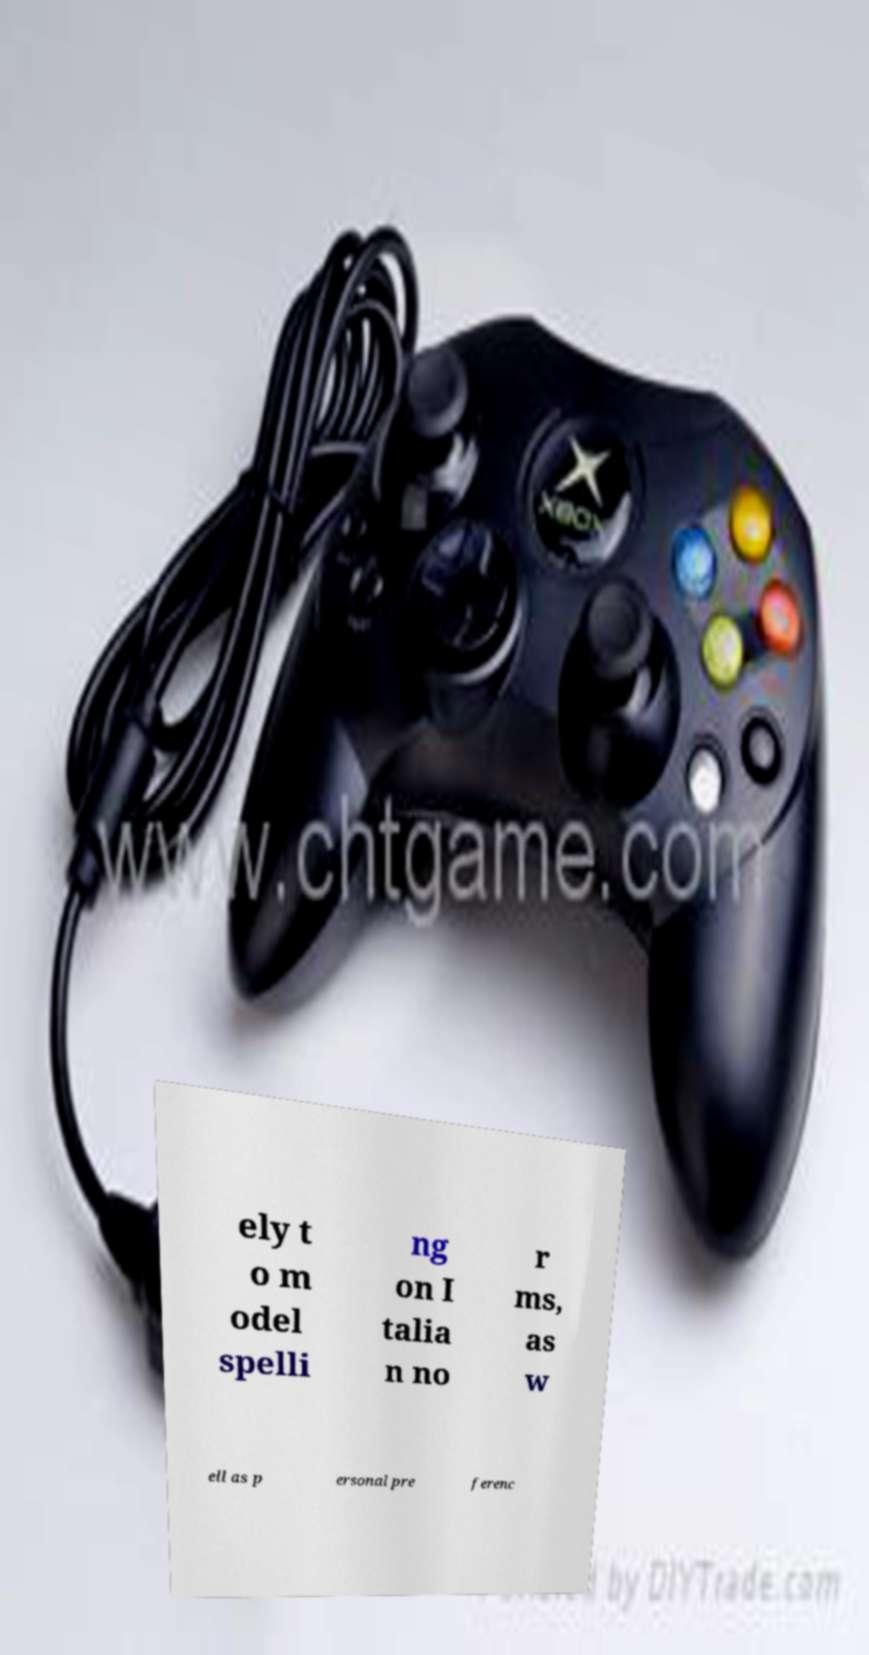I need the written content from this picture converted into text. Can you do that? ely t o m odel spelli ng on I talia n no r ms, as w ell as p ersonal pre ferenc 